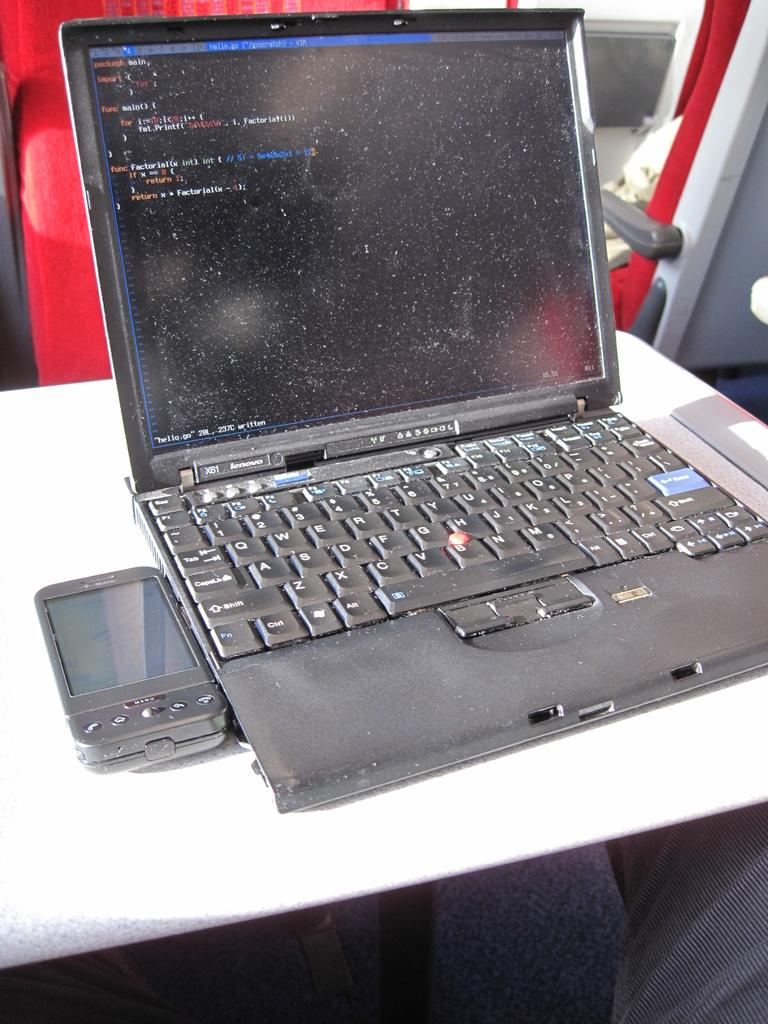Provide a one-sentence caption for the provided image. A lenovo laptop displaying a screen used to input code. 